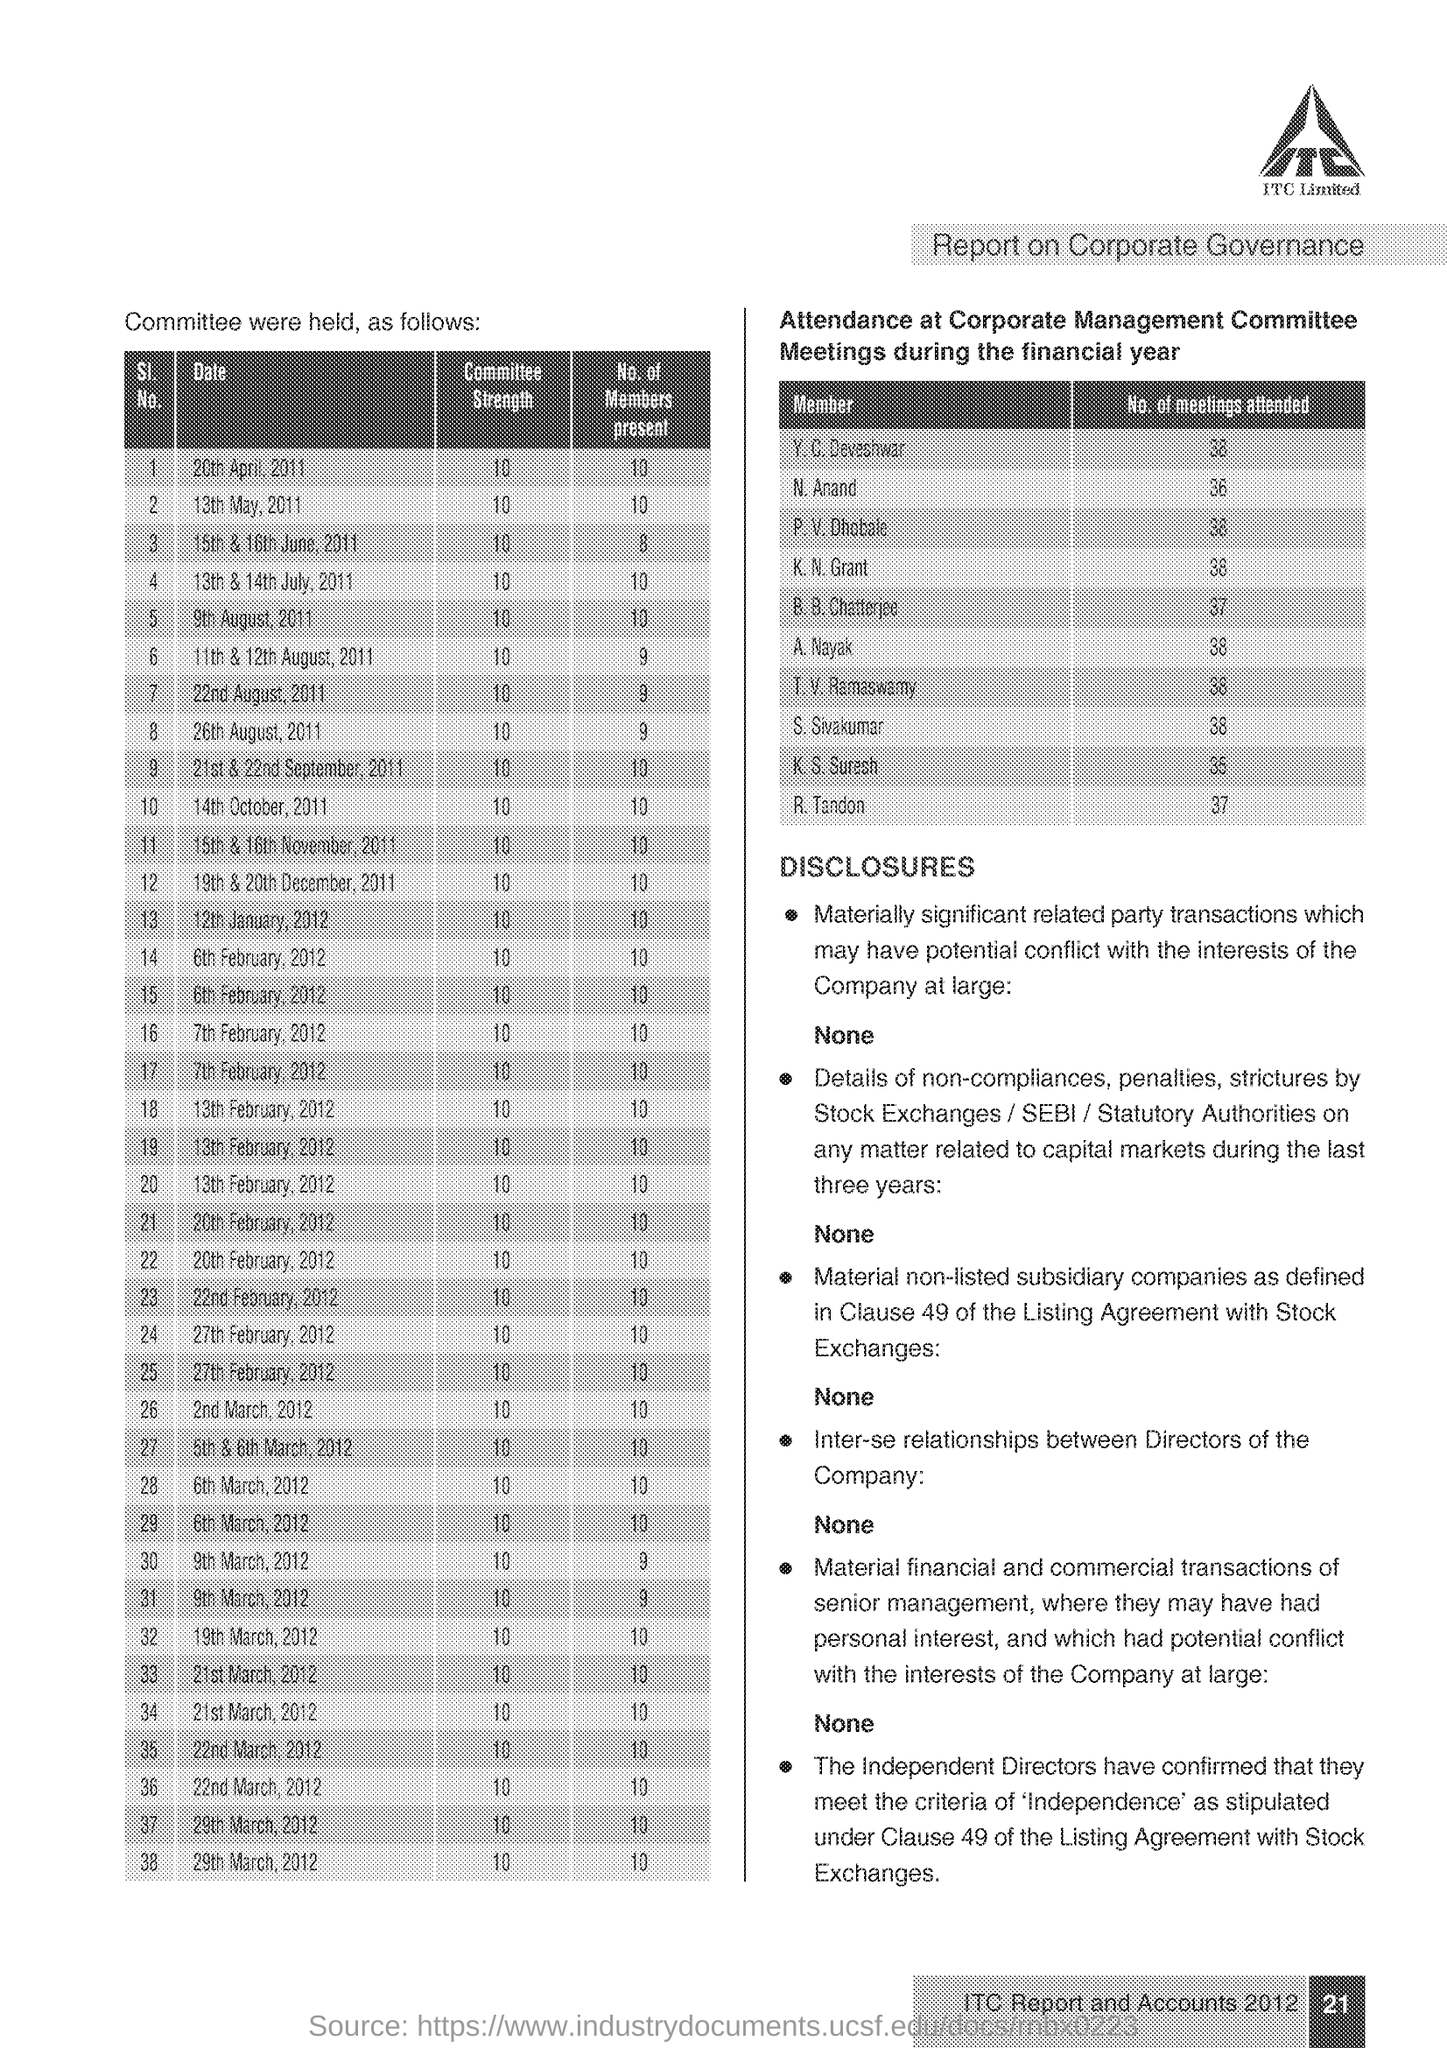Highlight a few significant elements in this photo. The number of members present on October 14, 2011, was 10. On May 13, 2011, the committee strength was 10. ITC Limited is a company. Anand N. attended 36 meetings. 